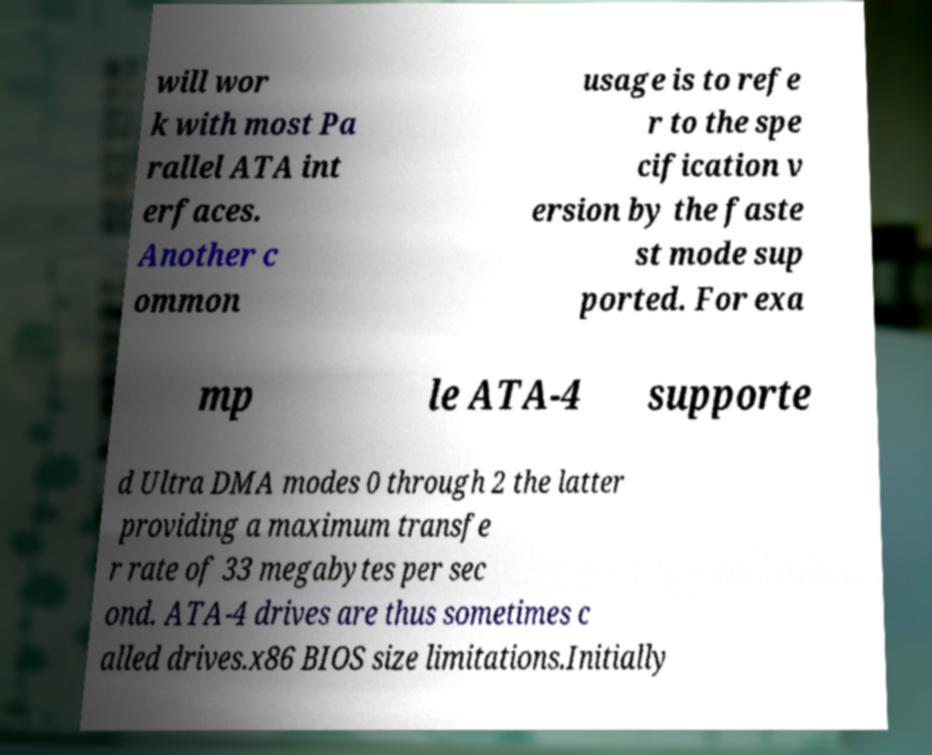Please read and relay the text visible in this image. What does it say? will wor k with most Pa rallel ATA int erfaces. Another c ommon usage is to refe r to the spe cification v ersion by the faste st mode sup ported. For exa mp le ATA-4 supporte d Ultra DMA modes 0 through 2 the latter providing a maximum transfe r rate of 33 megabytes per sec ond. ATA-4 drives are thus sometimes c alled drives.x86 BIOS size limitations.Initially 